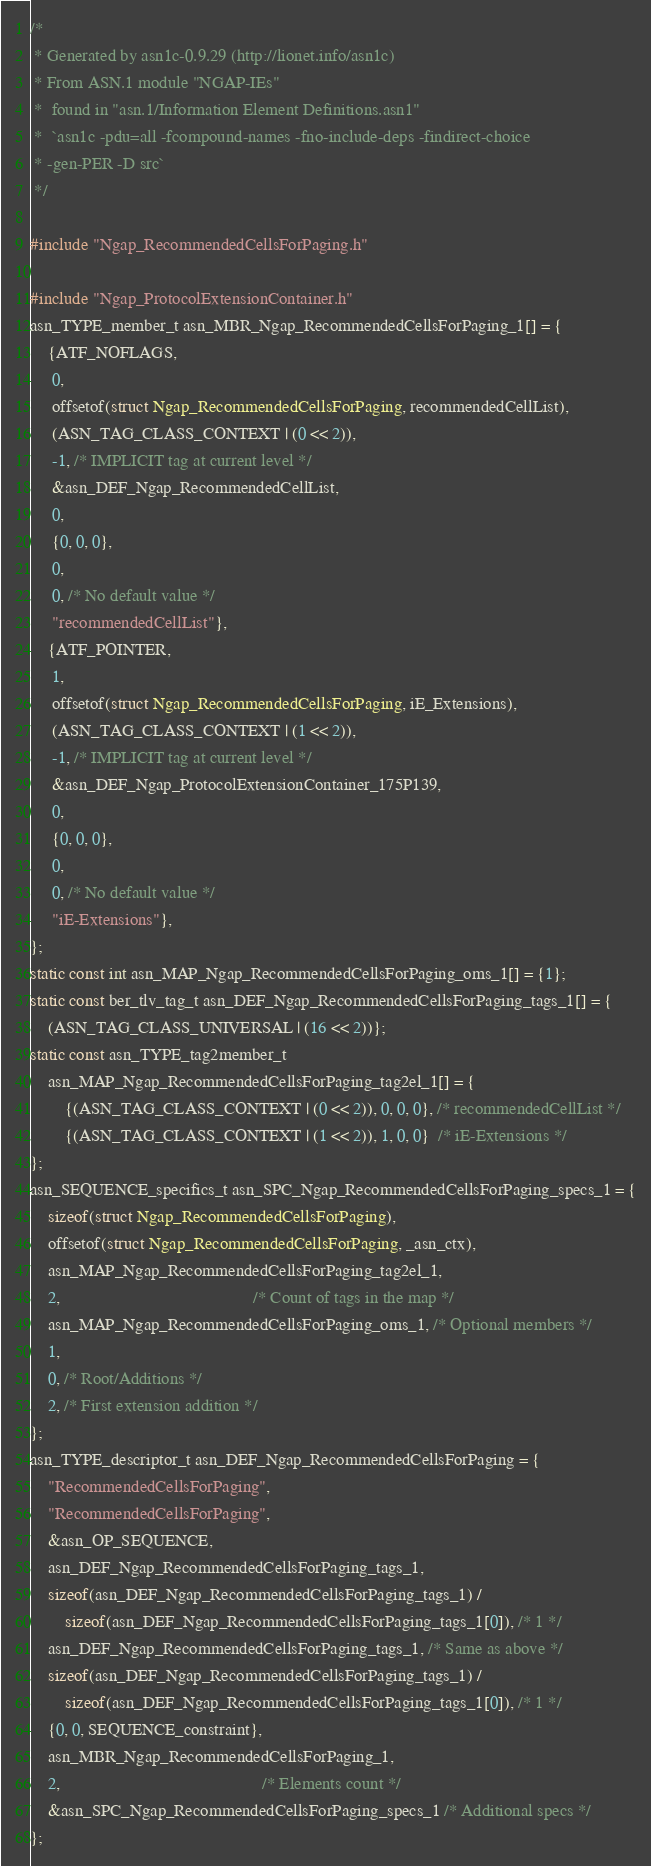<code> <loc_0><loc_0><loc_500><loc_500><_C_>/*
 * Generated by asn1c-0.9.29 (http://lionet.info/asn1c)
 * From ASN.1 module "NGAP-IEs"
 * 	found in "asn.1/Information Element Definitions.asn1"
 * 	`asn1c -pdu=all -fcompound-names -fno-include-deps -findirect-choice
 * -gen-PER -D src`
 */

#include "Ngap_RecommendedCellsForPaging.h"

#include "Ngap_ProtocolExtensionContainer.h"
asn_TYPE_member_t asn_MBR_Ngap_RecommendedCellsForPaging_1[] = {
    {ATF_NOFLAGS,
     0,
     offsetof(struct Ngap_RecommendedCellsForPaging, recommendedCellList),
     (ASN_TAG_CLASS_CONTEXT | (0 << 2)),
     -1, /* IMPLICIT tag at current level */
     &asn_DEF_Ngap_RecommendedCellList,
     0,
     {0, 0, 0},
     0,
     0, /* No default value */
     "recommendedCellList"},
    {ATF_POINTER,
     1,
     offsetof(struct Ngap_RecommendedCellsForPaging, iE_Extensions),
     (ASN_TAG_CLASS_CONTEXT | (1 << 2)),
     -1, /* IMPLICIT tag at current level */
     &asn_DEF_Ngap_ProtocolExtensionContainer_175P139,
     0,
     {0, 0, 0},
     0,
     0, /* No default value */
     "iE-Extensions"},
};
static const int asn_MAP_Ngap_RecommendedCellsForPaging_oms_1[] = {1};
static const ber_tlv_tag_t asn_DEF_Ngap_RecommendedCellsForPaging_tags_1[] = {
    (ASN_TAG_CLASS_UNIVERSAL | (16 << 2))};
static const asn_TYPE_tag2member_t
    asn_MAP_Ngap_RecommendedCellsForPaging_tag2el_1[] = {
        {(ASN_TAG_CLASS_CONTEXT | (0 << 2)), 0, 0, 0}, /* recommendedCellList */
        {(ASN_TAG_CLASS_CONTEXT | (1 << 2)), 1, 0, 0}  /* iE-Extensions */
};
asn_SEQUENCE_specifics_t asn_SPC_Ngap_RecommendedCellsForPaging_specs_1 = {
    sizeof(struct Ngap_RecommendedCellsForPaging),
    offsetof(struct Ngap_RecommendedCellsForPaging, _asn_ctx),
    asn_MAP_Ngap_RecommendedCellsForPaging_tag2el_1,
    2,                                            /* Count of tags in the map */
    asn_MAP_Ngap_RecommendedCellsForPaging_oms_1, /* Optional members */
    1,
    0, /* Root/Additions */
    2, /* First extension addition */
};
asn_TYPE_descriptor_t asn_DEF_Ngap_RecommendedCellsForPaging = {
    "RecommendedCellsForPaging",
    "RecommendedCellsForPaging",
    &asn_OP_SEQUENCE,
    asn_DEF_Ngap_RecommendedCellsForPaging_tags_1,
    sizeof(asn_DEF_Ngap_RecommendedCellsForPaging_tags_1) /
        sizeof(asn_DEF_Ngap_RecommendedCellsForPaging_tags_1[0]), /* 1 */
    asn_DEF_Ngap_RecommendedCellsForPaging_tags_1, /* Same as above */
    sizeof(asn_DEF_Ngap_RecommendedCellsForPaging_tags_1) /
        sizeof(asn_DEF_Ngap_RecommendedCellsForPaging_tags_1[0]), /* 1 */
    {0, 0, SEQUENCE_constraint},
    asn_MBR_Ngap_RecommendedCellsForPaging_1,
    2,                                              /* Elements count */
    &asn_SPC_Ngap_RecommendedCellsForPaging_specs_1 /* Additional specs */
};
</code> 